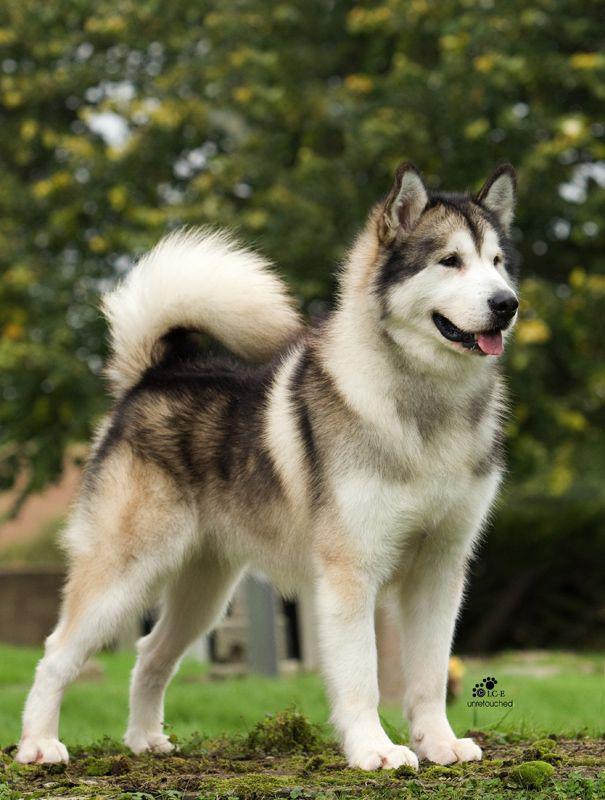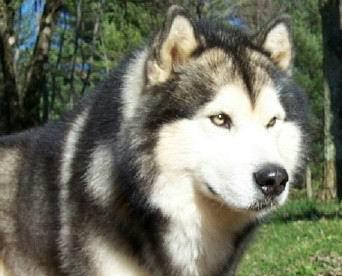The first image is the image on the left, the second image is the image on the right. For the images displayed, is the sentence "Each image contains one adult husky, and one of the dogs pictured stands on all fours with its mouth open and tongue hanging out." factually correct? Answer yes or no. Yes. The first image is the image on the left, the second image is the image on the right. Assess this claim about the two images: "The dog in the image on the left is standing in the grass.". Correct or not? Answer yes or no. Yes. 